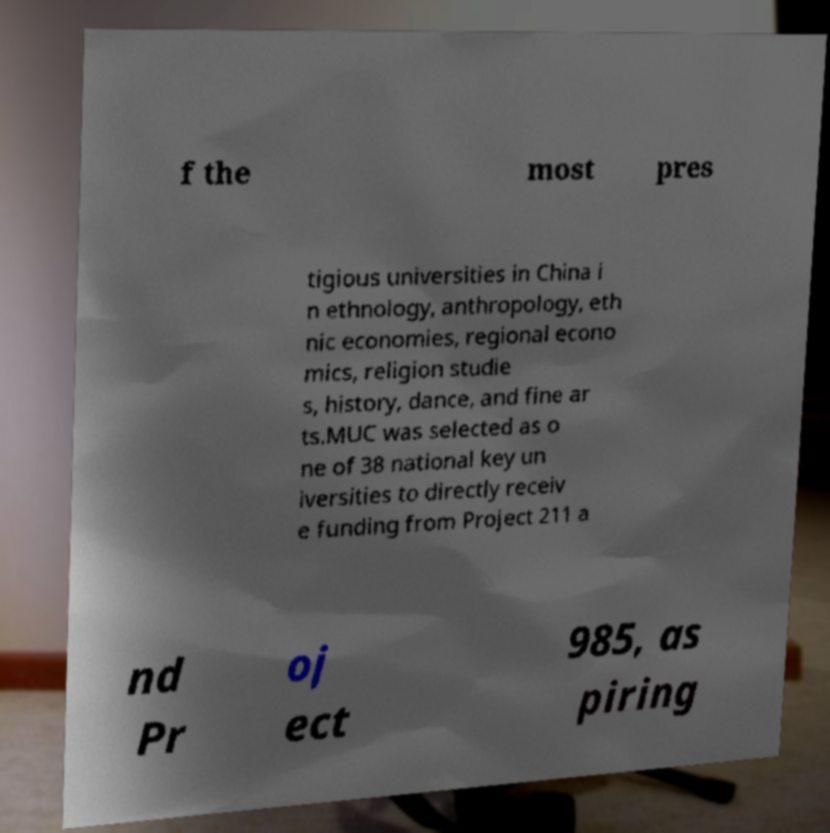Please read and relay the text visible in this image. What does it say? f the most pres tigious universities in China i n ethnology, anthropology, eth nic economies, regional econo mics, religion studie s, history, dance, and fine ar ts.MUC was selected as o ne of 38 national key un iversities to directly receiv e funding from Project 211 a nd Pr oj ect 985, as piring 